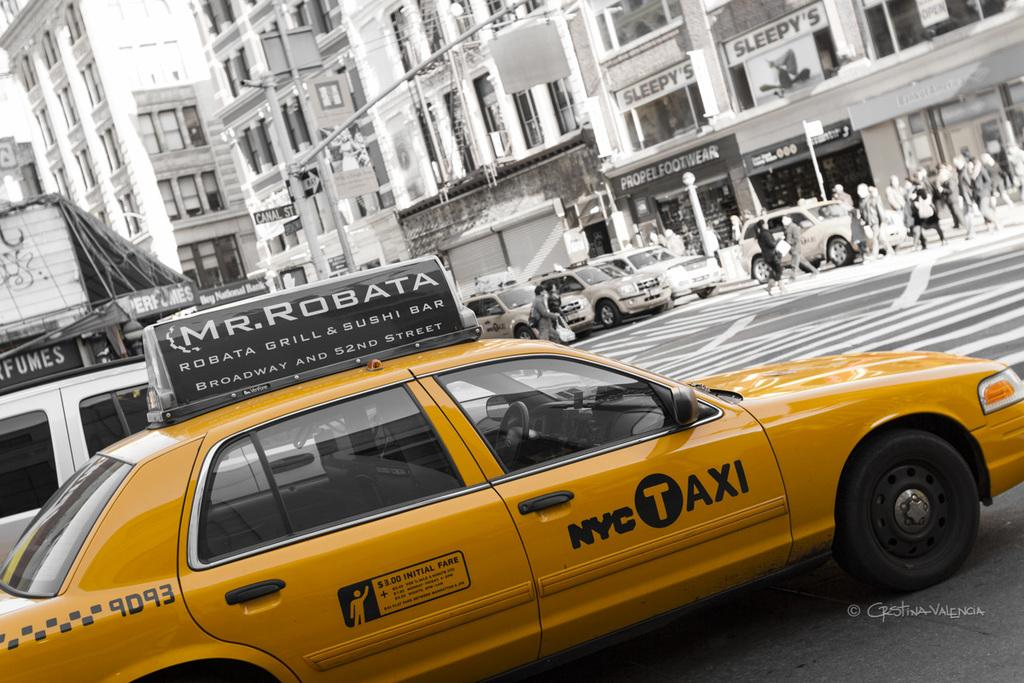Provide a one-sentence caption for the provided image. A yellow taxi cab advertises Mr. Robata on its roof. 